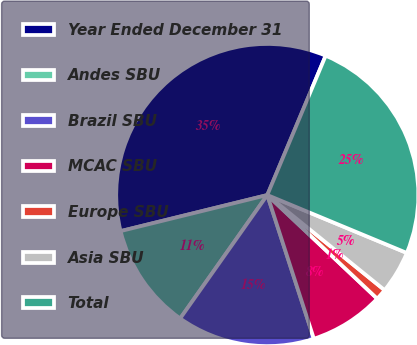Convert chart to OTSL. <chart><loc_0><loc_0><loc_500><loc_500><pie_chart><fcel>Year Ended December 31<fcel>Andes SBU<fcel>Brazil SBU<fcel>MCAC SBU<fcel>Europe SBU<fcel>Asia SBU<fcel>Total<nl><fcel>35.15%<fcel>11.38%<fcel>14.77%<fcel>7.98%<fcel>1.19%<fcel>4.58%<fcel>24.95%<nl></chart> 